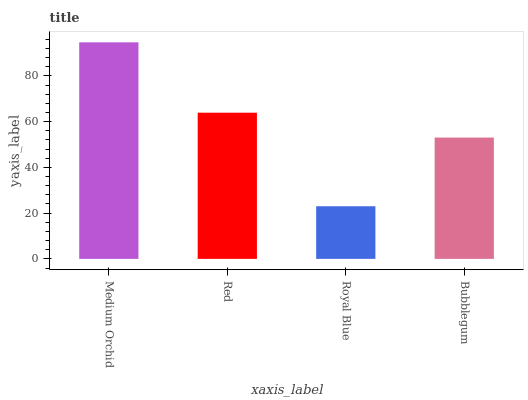Is Royal Blue the minimum?
Answer yes or no. Yes. Is Medium Orchid the maximum?
Answer yes or no. Yes. Is Red the minimum?
Answer yes or no. No. Is Red the maximum?
Answer yes or no. No. Is Medium Orchid greater than Red?
Answer yes or no. Yes. Is Red less than Medium Orchid?
Answer yes or no. Yes. Is Red greater than Medium Orchid?
Answer yes or no. No. Is Medium Orchid less than Red?
Answer yes or no. No. Is Red the high median?
Answer yes or no. Yes. Is Bubblegum the low median?
Answer yes or no. Yes. Is Royal Blue the high median?
Answer yes or no. No. Is Medium Orchid the low median?
Answer yes or no. No. 